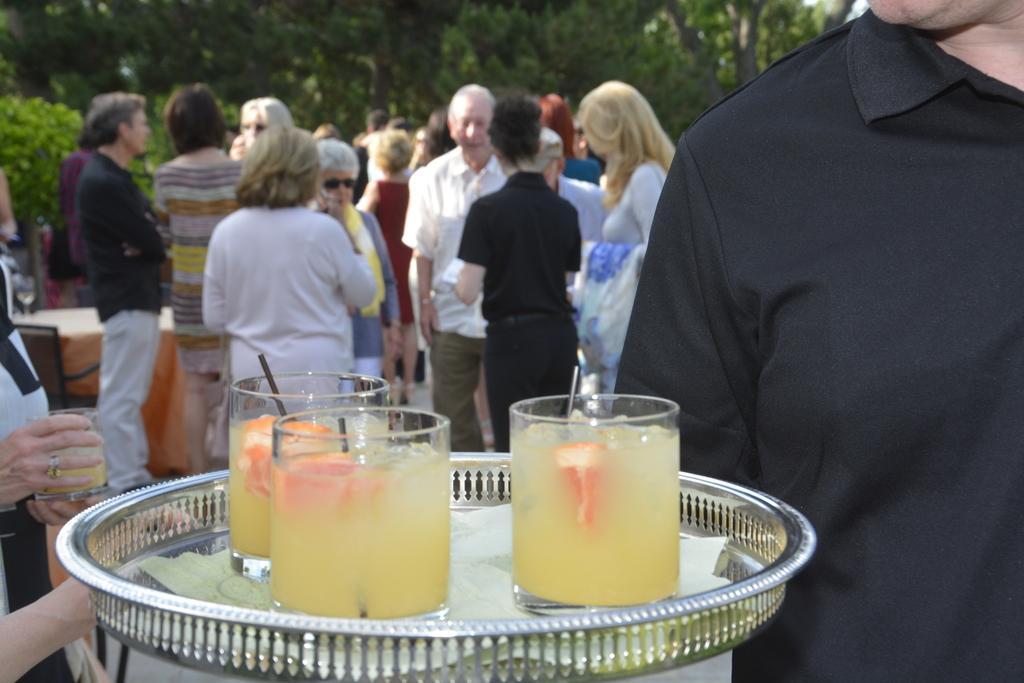Please provide a concise description of this image. In the middle of the image there is a tray with glasses. In the glasses there are drinks. On the right side of the image there is a man. And on the left side of the image there is a person standing and holding a glass. There are few people standing. Behind them there are trees in the background. 